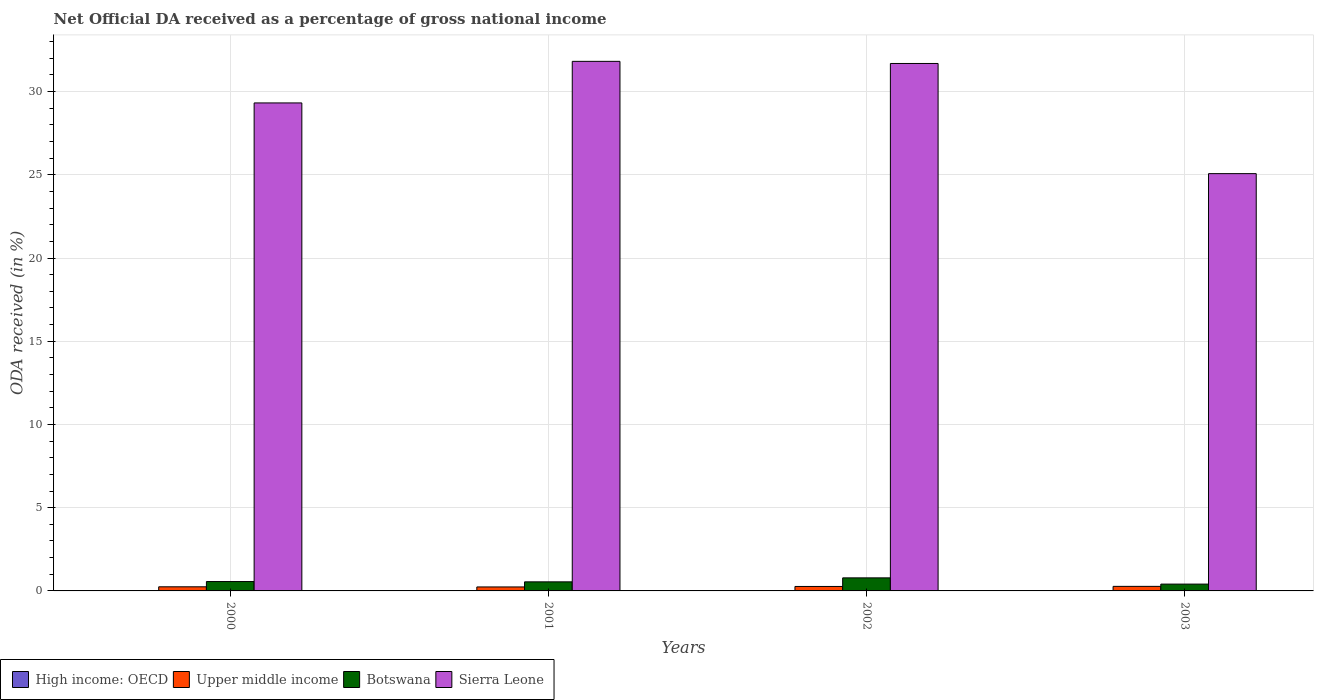How many groups of bars are there?
Keep it short and to the point. 4. Are the number of bars per tick equal to the number of legend labels?
Offer a very short reply. Yes. How many bars are there on the 3rd tick from the left?
Give a very brief answer. 4. What is the net official DA received in Botswana in 2001?
Provide a succinct answer. 0.54. Across all years, what is the maximum net official DA received in Sierra Leone?
Keep it short and to the point. 31.82. Across all years, what is the minimum net official DA received in Sierra Leone?
Provide a succinct answer. 25.07. In which year was the net official DA received in Botswana maximum?
Provide a succinct answer. 2002. What is the total net official DA received in Botswana in the graph?
Provide a succinct answer. 2.3. What is the difference between the net official DA received in Botswana in 2000 and that in 2003?
Offer a very short reply. 0.15. What is the difference between the net official DA received in High income: OECD in 2000 and the net official DA received in Botswana in 2002?
Give a very brief answer. -0.78. What is the average net official DA received in Sierra Leone per year?
Your answer should be compact. 29.47. In the year 2001, what is the difference between the net official DA received in High income: OECD and net official DA received in Botswana?
Give a very brief answer. -0.54. What is the ratio of the net official DA received in Botswana in 2001 to that in 2003?
Provide a short and direct response. 1.33. Is the difference between the net official DA received in High income: OECD in 2000 and 2001 greater than the difference between the net official DA received in Botswana in 2000 and 2001?
Provide a succinct answer. No. What is the difference between the highest and the second highest net official DA received in High income: OECD?
Your response must be concise. 0. What is the difference between the highest and the lowest net official DA received in Botswana?
Make the answer very short. 0.37. What does the 2nd bar from the left in 2003 represents?
Give a very brief answer. Upper middle income. What does the 4th bar from the right in 2003 represents?
Make the answer very short. High income: OECD. Is it the case that in every year, the sum of the net official DA received in Upper middle income and net official DA received in Botswana is greater than the net official DA received in High income: OECD?
Make the answer very short. Yes. How many years are there in the graph?
Your answer should be compact. 4. What is the difference between two consecutive major ticks on the Y-axis?
Provide a short and direct response. 5. Are the values on the major ticks of Y-axis written in scientific E-notation?
Your response must be concise. No. Does the graph contain grids?
Give a very brief answer. Yes. How many legend labels are there?
Provide a short and direct response. 4. What is the title of the graph?
Make the answer very short. Net Official DA received as a percentage of gross national income. Does "Poland" appear as one of the legend labels in the graph?
Ensure brevity in your answer.  No. What is the label or title of the Y-axis?
Provide a succinct answer. ODA received (in %). What is the ODA received (in %) in High income: OECD in 2000?
Give a very brief answer. 0. What is the ODA received (in %) in Upper middle income in 2000?
Offer a terse response. 0.25. What is the ODA received (in %) in Botswana in 2000?
Keep it short and to the point. 0.56. What is the ODA received (in %) in Sierra Leone in 2000?
Ensure brevity in your answer.  29.32. What is the ODA received (in %) of High income: OECD in 2001?
Offer a very short reply. 0. What is the ODA received (in %) in Upper middle income in 2001?
Your answer should be compact. 0.24. What is the ODA received (in %) of Botswana in 2001?
Your answer should be very brief. 0.54. What is the ODA received (in %) in Sierra Leone in 2001?
Your answer should be compact. 31.82. What is the ODA received (in %) of High income: OECD in 2002?
Offer a terse response. 0. What is the ODA received (in %) in Upper middle income in 2002?
Give a very brief answer. 0.27. What is the ODA received (in %) of Botswana in 2002?
Keep it short and to the point. 0.78. What is the ODA received (in %) of Sierra Leone in 2002?
Give a very brief answer. 31.69. What is the ODA received (in %) in High income: OECD in 2003?
Give a very brief answer. 0. What is the ODA received (in %) of Upper middle income in 2003?
Your response must be concise. 0.27. What is the ODA received (in %) of Botswana in 2003?
Keep it short and to the point. 0.41. What is the ODA received (in %) of Sierra Leone in 2003?
Provide a short and direct response. 25.07. Across all years, what is the maximum ODA received (in %) in High income: OECD?
Offer a very short reply. 0. Across all years, what is the maximum ODA received (in %) of Upper middle income?
Offer a very short reply. 0.27. Across all years, what is the maximum ODA received (in %) of Botswana?
Offer a very short reply. 0.78. Across all years, what is the maximum ODA received (in %) in Sierra Leone?
Your answer should be very brief. 31.82. Across all years, what is the minimum ODA received (in %) in High income: OECD?
Keep it short and to the point. 0. Across all years, what is the minimum ODA received (in %) of Upper middle income?
Keep it short and to the point. 0.24. Across all years, what is the minimum ODA received (in %) in Botswana?
Your answer should be compact. 0.41. Across all years, what is the minimum ODA received (in %) of Sierra Leone?
Your answer should be compact. 25.07. What is the total ODA received (in %) in High income: OECD in the graph?
Your answer should be very brief. 0. What is the total ODA received (in %) of Upper middle income in the graph?
Offer a very short reply. 1.03. What is the total ODA received (in %) in Botswana in the graph?
Your answer should be very brief. 2.3. What is the total ODA received (in %) of Sierra Leone in the graph?
Your answer should be compact. 117.9. What is the difference between the ODA received (in %) in High income: OECD in 2000 and that in 2001?
Provide a succinct answer. -0. What is the difference between the ODA received (in %) of Upper middle income in 2000 and that in 2001?
Provide a short and direct response. 0.01. What is the difference between the ODA received (in %) in Botswana in 2000 and that in 2001?
Your answer should be very brief. 0.02. What is the difference between the ODA received (in %) in Sierra Leone in 2000 and that in 2001?
Give a very brief answer. -2.5. What is the difference between the ODA received (in %) in Upper middle income in 2000 and that in 2002?
Offer a very short reply. -0.02. What is the difference between the ODA received (in %) in Botswana in 2000 and that in 2002?
Make the answer very short. -0.22. What is the difference between the ODA received (in %) of Sierra Leone in 2000 and that in 2002?
Your response must be concise. -2.37. What is the difference between the ODA received (in %) in High income: OECD in 2000 and that in 2003?
Your response must be concise. 0. What is the difference between the ODA received (in %) of Upper middle income in 2000 and that in 2003?
Your response must be concise. -0.03. What is the difference between the ODA received (in %) of Botswana in 2000 and that in 2003?
Offer a terse response. 0.15. What is the difference between the ODA received (in %) of Sierra Leone in 2000 and that in 2003?
Give a very brief answer. 4.25. What is the difference between the ODA received (in %) in High income: OECD in 2001 and that in 2002?
Your answer should be compact. 0. What is the difference between the ODA received (in %) in Upper middle income in 2001 and that in 2002?
Provide a succinct answer. -0.03. What is the difference between the ODA received (in %) of Botswana in 2001 and that in 2002?
Make the answer very short. -0.24. What is the difference between the ODA received (in %) of Sierra Leone in 2001 and that in 2002?
Ensure brevity in your answer.  0.13. What is the difference between the ODA received (in %) in High income: OECD in 2001 and that in 2003?
Keep it short and to the point. 0. What is the difference between the ODA received (in %) of Upper middle income in 2001 and that in 2003?
Offer a terse response. -0.03. What is the difference between the ODA received (in %) of Botswana in 2001 and that in 2003?
Offer a terse response. 0.14. What is the difference between the ODA received (in %) in Sierra Leone in 2001 and that in 2003?
Your answer should be very brief. 6.75. What is the difference between the ODA received (in %) in High income: OECD in 2002 and that in 2003?
Make the answer very short. -0. What is the difference between the ODA received (in %) in Upper middle income in 2002 and that in 2003?
Provide a short and direct response. -0.01. What is the difference between the ODA received (in %) of Botswana in 2002 and that in 2003?
Offer a very short reply. 0.37. What is the difference between the ODA received (in %) in Sierra Leone in 2002 and that in 2003?
Your response must be concise. 6.62. What is the difference between the ODA received (in %) in High income: OECD in 2000 and the ODA received (in %) in Upper middle income in 2001?
Offer a very short reply. -0.24. What is the difference between the ODA received (in %) in High income: OECD in 2000 and the ODA received (in %) in Botswana in 2001?
Offer a terse response. -0.54. What is the difference between the ODA received (in %) in High income: OECD in 2000 and the ODA received (in %) in Sierra Leone in 2001?
Ensure brevity in your answer.  -31.82. What is the difference between the ODA received (in %) of Upper middle income in 2000 and the ODA received (in %) of Botswana in 2001?
Provide a short and direct response. -0.3. What is the difference between the ODA received (in %) of Upper middle income in 2000 and the ODA received (in %) of Sierra Leone in 2001?
Your answer should be very brief. -31.57. What is the difference between the ODA received (in %) in Botswana in 2000 and the ODA received (in %) in Sierra Leone in 2001?
Your response must be concise. -31.25. What is the difference between the ODA received (in %) of High income: OECD in 2000 and the ODA received (in %) of Upper middle income in 2002?
Provide a short and direct response. -0.27. What is the difference between the ODA received (in %) in High income: OECD in 2000 and the ODA received (in %) in Botswana in 2002?
Make the answer very short. -0.78. What is the difference between the ODA received (in %) in High income: OECD in 2000 and the ODA received (in %) in Sierra Leone in 2002?
Your answer should be very brief. -31.69. What is the difference between the ODA received (in %) of Upper middle income in 2000 and the ODA received (in %) of Botswana in 2002?
Make the answer very short. -0.54. What is the difference between the ODA received (in %) in Upper middle income in 2000 and the ODA received (in %) in Sierra Leone in 2002?
Keep it short and to the point. -31.44. What is the difference between the ODA received (in %) in Botswana in 2000 and the ODA received (in %) in Sierra Leone in 2002?
Offer a terse response. -31.13. What is the difference between the ODA received (in %) of High income: OECD in 2000 and the ODA received (in %) of Upper middle income in 2003?
Give a very brief answer. -0.27. What is the difference between the ODA received (in %) of High income: OECD in 2000 and the ODA received (in %) of Botswana in 2003?
Provide a short and direct response. -0.41. What is the difference between the ODA received (in %) in High income: OECD in 2000 and the ODA received (in %) in Sierra Leone in 2003?
Offer a terse response. -25.07. What is the difference between the ODA received (in %) of Upper middle income in 2000 and the ODA received (in %) of Botswana in 2003?
Your answer should be compact. -0.16. What is the difference between the ODA received (in %) of Upper middle income in 2000 and the ODA received (in %) of Sierra Leone in 2003?
Keep it short and to the point. -24.82. What is the difference between the ODA received (in %) in Botswana in 2000 and the ODA received (in %) in Sierra Leone in 2003?
Make the answer very short. -24.51. What is the difference between the ODA received (in %) of High income: OECD in 2001 and the ODA received (in %) of Upper middle income in 2002?
Offer a terse response. -0.27. What is the difference between the ODA received (in %) of High income: OECD in 2001 and the ODA received (in %) of Botswana in 2002?
Your answer should be very brief. -0.78. What is the difference between the ODA received (in %) of High income: OECD in 2001 and the ODA received (in %) of Sierra Leone in 2002?
Offer a terse response. -31.69. What is the difference between the ODA received (in %) of Upper middle income in 2001 and the ODA received (in %) of Botswana in 2002?
Ensure brevity in your answer.  -0.55. What is the difference between the ODA received (in %) of Upper middle income in 2001 and the ODA received (in %) of Sierra Leone in 2002?
Make the answer very short. -31.45. What is the difference between the ODA received (in %) of Botswana in 2001 and the ODA received (in %) of Sierra Leone in 2002?
Offer a terse response. -31.14. What is the difference between the ODA received (in %) of High income: OECD in 2001 and the ODA received (in %) of Upper middle income in 2003?
Keep it short and to the point. -0.27. What is the difference between the ODA received (in %) in High income: OECD in 2001 and the ODA received (in %) in Botswana in 2003?
Offer a terse response. -0.41. What is the difference between the ODA received (in %) of High income: OECD in 2001 and the ODA received (in %) of Sierra Leone in 2003?
Your response must be concise. -25.07. What is the difference between the ODA received (in %) of Upper middle income in 2001 and the ODA received (in %) of Botswana in 2003?
Offer a very short reply. -0.17. What is the difference between the ODA received (in %) of Upper middle income in 2001 and the ODA received (in %) of Sierra Leone in 2003?
Make the answer very short. -24.83. What is the difference between the ODA received (in %) of Botswana in 2001 and the ODA received (in %) of Sierra Leone in 2003?
Make the answer very short. -24.53. What is the difference between the ODA received (in %) of High income: OECD in 2002 and the ODA received (in %) of Upper middle income in 2003?
Your answer should be compact. -0.27. What is the difference between the ODA received (in %) in High income: OECD in 2002 and the ODA received (in %) in Botswana in 2003?
Your answer should be compact. -0.41. What is the difference between the ODA received (in %) in High income: OECD in 2002 and the ODA received (in %) in Sierra Leone in 2003?
Give a very brief answer. -25.07. What is the difference between the ODA received (in %) of Upper middle income in 2002 and the ODA received (in %) of Botswana in 2003?
Ensure brevity in your answer.  -0.14. What is the difference between the ODA received (in %) in Upper middle income in 2002 and the ODA received (in %) in Sierra Leone in 2003?
Your response must be concise. -24.8. What is the difference between the ODA received (in %) of Botswana in 2002 and the ODA received (in %) of Sierra Leone in 2003?
Make the answer very short. -24.29. What is the average ODA received (in %) of Upper middle income per year?
Keep it short and to the point. 0.26. What is the average ODA received (in %) of Botswana per year?
Offer a terse response. 0.58. What is the average ODA received (in %) of Sierra Leone per year?
Keep it short and to the point. 29.47. In the year 2000, what is the difference between the ODA received (in %) in High income: OECD and ODA received (in %) in Upper middle income?
Ensure brevity in your answer.  -0.25. In the year 2000, what is the difference between the ODA received (in %) of High income: OECD and ODA received (in %) of Botswana?
Provide a succinct answer. -0.56. In the year 2000, what is the difference between the ODA received (in %) of High income: OECD and ODA received (in %) of Sierra Leone?
Make the answer very short. -29.32. In the year 2000, what is the difference between the ODA received (in %) in Upper middle income and ODA received (in %) in Botswana?
Keep it short and to the point. -0.32. In the year 2000, what is the difference between the ODA received (in %) in Upper middle income and ODA received (in %) in Sierra Leone?
Ensure brevity in your answer.  -29.07. In the year 2000, what is the difference between the ODA received (in %) in Botswana and ODA received (in %) in Sierra Leone?
Provide a succinct answer. -28.76. In the year 2001, what is the difference between the ODA received (in %) in High income: OECD and ODA received (in %) in Upper middle income?
Offer a very short reply. -0.24. In the year 2001, what is the difference between the ODA received (in %) of High income: OECD and ODA received (in %) of Botswana?
Provide a succinct answer. -0.54. In the year 2001, what is the difference between the ODA received (in %) in High income: OECD and ODA received (in %) in Sierra Leone?
Keep it short and to the point. -31.82. In the year 2001, what is the difference between the ODA received (in %) in Upper middle income and ODA received (in %) in Botswana?
Provide a succinct answer. -0.31. In the year 2001, what is the difference between the ODA received (in %) of Upper middle income and ODA received (in %) of Sierra Leone?
Keep it short and to the point. -31.58. In the year 2001, what is the difference between the ODA received (in %) in Botswana and ODA received (in %) in Sierra Leone?
Your response must be concise. -31.27. In the year 2002, what is the difference between the ODA received (in %) in High income: OECD and ODA received (in %) in Upper middle income?
Provide a short and direct response. -0.27. In the year 2002, what is the difference between the ODA received (in %) of High income: OECD and ODA received (in %) of Botswana?
Offer a terse response. -0.78. In the year 2002, what is the difference between the ODA received (in %) of High income: OECD and ODA received (in %) of Sierra Leone?
Your response must be concise. -31.69. In the year 2002, what is the difference between the ODA received (in %) in Upper middle income and ODA received (in %) in Botswana?
Offer a very short reply. -0.52. In the year 2002, what is the difference between the ODA received (in %) in Upper middle income and ODA received (in %) in Sierra Leone?
Offer a terse response. -31.42. In the year 2002, what is the difference between the ODA received (in %) in Botswana and ODA received (in %) in Sierra Leone?
Your answer should be very brief. -30.91. In the year 2003, what is the difference between the ODA received (in %) of High income: OECD and ODA received (in %) of Upper middle income?
Make the answer very short. -0.27. In the year 2003, what is the difference between the ODA received (in %) in High income: OECD and ODA received (in %) in Botswana?
Give a very brief answer. -0.41. In the year 2003, what is the difference between the ODA received (in %) of High income: OECD and ODA received (in %) of Sierra Leone?
Your response must be concise. -25.07. In the year 2003, what is the difference between the ODA received (in %) of Upper middle income and ODA received (in %) of Botswana?
Ensure brevity in your answer.  -0.14. In the year 2003, what is the difference between the ODA received (in %) of Upper middle income and ODA received (in %) of Sierra Leone?
Make the answer very short. -24.8. In the year 2003, what is the difference between the ODA received (in %) in Botswana and ODA received (in %) in Sierra Leone?
Offer a terse response. -24.66. What is the ratio of the ODA received (in %) in High income: OECD in 2000 to that in 2001?
Provide a short and direct response. 0.54. What is the ratio of the ODA received (in %) in Upper middle income in 2000 to that in 2001?
Your answer should be very brief. 1.03. What is the ratio of the ODA received (in %) of Botswana in 2000 to that in 2001?
Offer a very short reply. 1.03. What is the ratio of the ODA received (in %) in Sierra Leone in 2000 to that in 2001?
Offer a terse response. 0.92. What is the ratio of the ODA received (in %) of High income: OECD in 2000 to that in 2002?
Give a very brief answer. 2.5. What is the ratio of the ODA received (in %) in Upper middle income in 2000 to that in 2002?
Offer a very short reply. 0.92. What is the ratio of the ODA received (in %) in Botswana in 2000 to that in 2002?
Offer a terse response. 0.72. What is the ratio of the ODA received (in %) in Sierra Leone in 2000 to that in 2002?
Offer a very short reply. 0.93. What is the ratio of the ODA received (in %) of High income: OECD in 2000 to that in 2003?
Provide a short and direct response. 1.49. What is the ratio of the ODA received (in %) of Upper middle income in 2000 to that in 2003?
Give a very brief answer. 0.9. What is the ratio of the ODA received (in %) in Botswana in 2000 to that in 2003?
Your answer should be very brief. 1.37. What is the ratio of the ODA received (in %) of Sierra Leone in 2000 to that in 2003?
Offer a terse response. 1.17. What is the ratio of the ODA received (in %) of High income: OECD in 2001 to that in 2002?
Offer a very short reply. 4.6. What is the ratio of the ODA received (in %) in Upper middle income in 2001 to that in 2002?
Provide a short and direct response. 0.89. What is the ratio of the ODA received (in %) in Botswana in 2001 to that in 2002?
Offer a terse response. 0.69. What is the ratio of the ODA received (in %) of High income: OECD in 2001 to that in 2003?
Your response must be concise. 2.74. What is the ratio of the ODA received (in %) of Upper middle income in 2001 to that in 2003?
Your answer should be very brief. 0.87. What is the ratio of the ODA received (in %) in Botswana in 2001 to that in 2003?
Offer a very short reply. 1.33. What is the ratio of the ODA received (in %) of Sierra Leone in 2001 to that in 2003?
Your response must be concise. 1.27. What is the ratio of the ODA received (in %) of High income: OECD in 2002 to that in 2003?
Keep it short and to the point. 0.6. What is the ratio of the ODA received (in %) of Botswana in 2002 to that in 2003?
Your answer should be very brief. 1.91. What is the ratio of the ODA received (in %) in Sierra Leone in 2002 to that in 2003?
Your response must be concise. 1.26. What is the difference between the highest and the second highest ODA received (in %) of Upper middle income?
Your answer should be very brief. 0.01. What is the difference between the highest and the second highest ODA received (in %) of Botswana?
Offer a very short reply. 0.22. What is the difference between the highest and the second highest ODA received (in %) of Sierra Leone?
Provide a short and direct response. 0.13. What is the difference between the highest and the lowest ODA received (in %) of High income: OECD?
Provide a short and direct response. 0. What is the difference between the highest and the lowest ODA received (in %) in Upper middle income?
Make the answer very short. 0.03. What is the difference between the highest and the lowest ODA received (in %) in Botswana?
Your answer should be compact. 0.37. What is the difference between the highest and the lowest ODA received (in %) of Sierra Leone?
Keep it short and to the point. 6.75. 